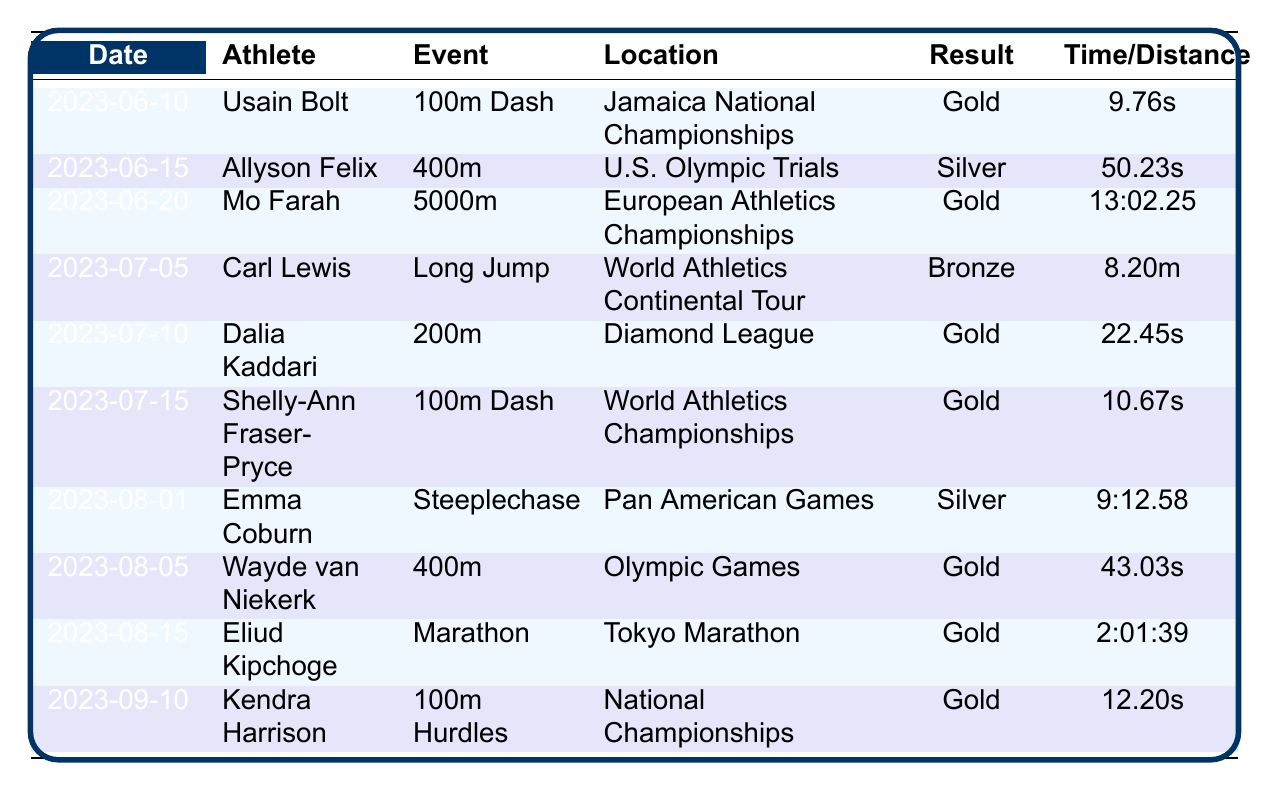What athlete participated in the 400m event on June 15, 2023? The table lists the athlete and the event for each date. On June 15, 2023, Allyson Felix is noted as participating in the 400m event.
Answer: Allyson Felix Which athlete achieved a Gold result in the 100m Dash? By reviewing the results of the 100m Dash events, I can see that Usain Bolt won Gold on June 10, 2023, and Shelly-Ann Fraser-Pryce also won Gold on July 15, 2023.
Answer: Usain Bolt and Shelly-Ann Fraser-Pryce How many athletes won a Gold medal in total? To find the total number of Gold medals, I look through each result in the table and count. Usain Bolt, Mo Farah, Dalia Kaddari, Shelly-Ann Fraser-Pryce, Wayde van Niekerk, Eliud Kipchoge, and Kendra Harrison all won Gold, totaling 7 athletes.
Answer: 7 What is the average time for the 400m event participants? The times for the 400m events are 50.23s (Allyson Felix) and 43.03s (Wayde van Niekerk). I convert both times to seconds: 50.23 and 43.03. The average is (50.23 + 43.03) / 2 = 46.63 seconds.
Answer: 46.63 seconds Did anyone compete in a Marathon event in the table? Looking through the table, Eliud Kipchoge is the only athlete listed who participated in a Marathon, achieving a Gold result on August 15, 2023.
Answer: Yes What was the result of the athlete who competed in the Long Jump on July 5, 2023? Checking the event on July 5, 2023, Carl Lewis is listed as having competed in the Long Jump, where he achieved a Bronze result.
Answer: Bronze Who had the fastest time in the 100m Dash during these competitions? I compare the times for both the athletes in the 100m Dash: Usain Bolt’s time is 9.76s, and Shelly-Ann Fraser-Pryce’s time is 10.67s. The fastest time is 9.76s from Usain Bolt.
Answer: 9.76 seconds What was the distance in the Long Jump event? The table specifies that Carl Lewis performed a Long Jump of 8.20m on July 5, 2023.
Answer: 8.20m Is there any athlete who won a Silver medal in the events listed? Upon reviewing the results, both Allyson Felix (400m on June 15, 2023) and Emma Coburn (Steeplechase on August 1, 2023) achieved Silver medals.
Answer: Yes Which event did Mo Farah win Gold in, and what was his time? Mo Farah competed in the 5000m event on June 20, 2023, achieving a Gold result with a time of 13:02.25.
Answer: 5000m, 13:02.25 